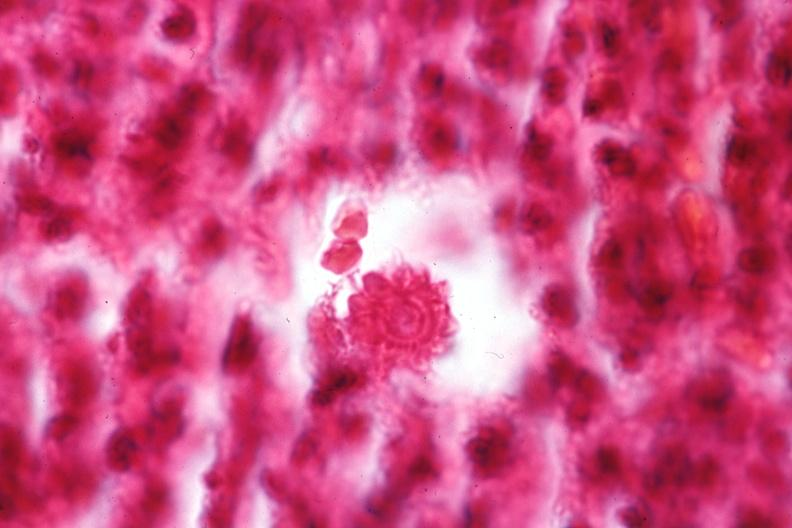where is this?
Answer the question using a single word or phrase. Skin 